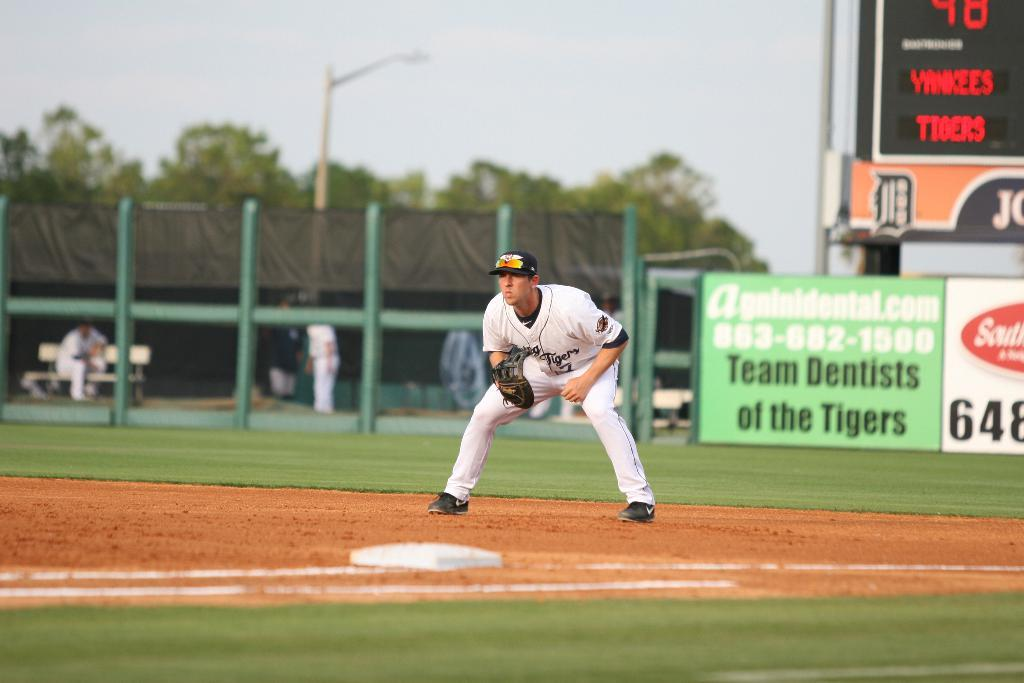<image>
Share a concise interpretation of the image provided. a baseball player on a field with ads for Team Dentists of the Tigers 